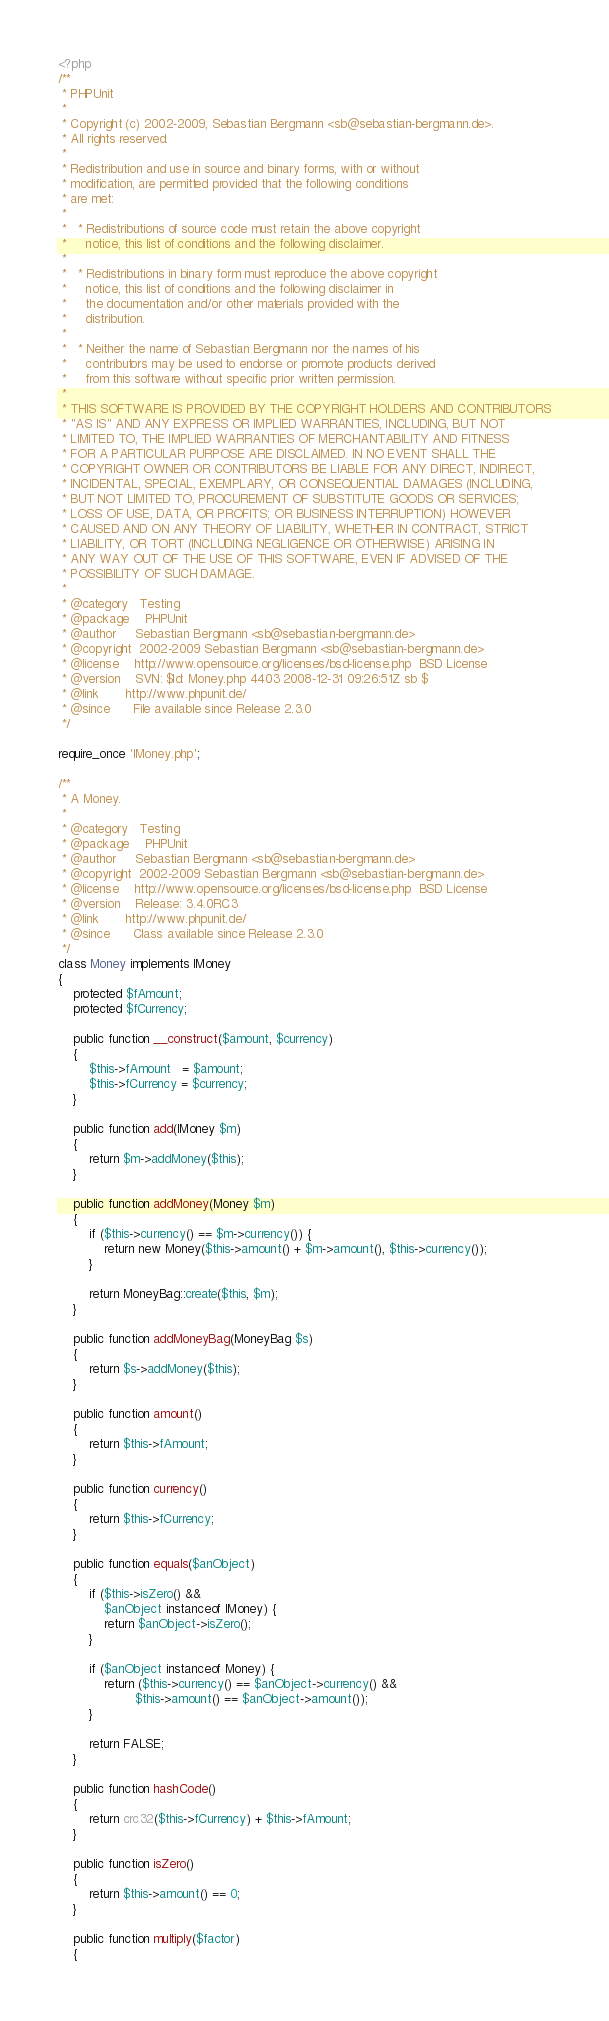<code> <loc_0><loc_0><loc_500><loc_500><_PHP_><?php
/**
 * PHPUnit
 *
 * Copyright (c) 2002-2009, Sebastian Bergmann <sb@sebastian-bergmann.de>.
 * All rights reserved.
 *
 * Redistribution and use in source and binary forms, with or without
 * modification, are permitted provided that the following conditions
 * are met:
 *
 *   * Redistributions of source code must retain the above copyright
 *     notice, this list of conditions and the following disclaimer.
 *
 *   * Redistributions in binary form must reproduce the above copyright
 *     notice, this list of conditions and the following disclaimer in
 *     the documentation and/or other materials provided with the
 *     distribution.
 *
 *   * Neither the name of Sebastian Bergmann nor the names of his
 *     contributors may be used to endorse or promote products derived
 *     from this software without specific prior written permission.
 *
 * THIS SOFTWARE IS PROVIDED BY THE COPYRIGHT HOLDERS AND CONTRIBUTORS
 * "AS IS" AND ANY EXPRESS OR IMPLIED WARRANTIES, INCLUDING, BUT NOT
 * LIMITED TO, THE IMPLIED WARRANTIES OF MERCHANTABILITY AND FITNESS
 * FOR A PARTICULAR PURPOSE ARE DISCLAIMED. IN NO EVENT SHALL THE
 * COPYRIGHT OWNER OR CONTRIBUTORS BE LIABLE FOR ANY DIRECT, INDIRECT,
 * INCIDENTAL, SPECIAL, EXEMPLARY, OR CONSEQUENTIAL DAMAGES (INCLUDING,
 * BUT NOT LIMITED TO, PROCUREMENT OF SUBSTITUTE GOODS OR SERVICES;
 * LOSS OF USE, DATA, OR PROFITS; OR BUSINESS INTERRUPTION) HOWEVER
 * CAUSED AND ON ANY THEORY OF LIABILITY, WHETHER IN CONTRACT, STRICT
 * LIABILITY, OR TORT (INCLUDING NEGLIGENCE OR OTHERWISE) ARISING IN
 * ANY WAY OUT OF THE USE OF THIS SOFTWARE, EVEN IF ADVISED OF THE
 * POSSIBILITY OF SUCH DAMAGE.
 *
 * @category   Testing
 * @package    PHPUnit
 * @author     Sebastian Bergmann <sb@sebastian-bergmann.de>
 * @copyright  2002-2009 Sebastian Bergmann <sb@sebastian-bergmann.de>
 * @license    http://www.opensource.org/licenses/bsd-license.php  BSD License
 * @version    SVN: $Id: Money.php 4403 2008-12-31 09:26:51Z sb $
 * @link       http://www.phpunit.de/
 * @since      File available since Release 2.3.0
 */

require_once 'IMoney.php';

/**
 * A Money.
 *
 * @category   Testing
 * @package    PHPUnit
 * @author     Sebastian Bergmann <sb@sebastian-bergmann.de>
 * @copyright  2002-2009 Sebastian Bergmann <sb@sebastian-bergmann.de>
 * @license    http://www.opensource.org/licenses/bsd-license.php  BSD License
 * @version    Release: 3.4.0RC3
 * @link       http://www.phpunit.de/
 * @since      Class available since Release 2.3.0
 */
class Money implements IMoney
{
    protected $fAmount;
    protected $fCurrency;

    public function __construct($amount, $currency)
    {
        $this->fAmount   = $amount;
        $this->fCurrency = $currency;
    }

    public function add(IMoney $m)
    {
        return $m->addMoney($this);
    }

    public function addMoney(Money $m)
    {
        if ($this->currency() == $m->currency()) {
            return new Money($this->amount() + $m->amount(), $this->currency());
        }

        return MoneyBag::create($this, $m);
    }

    public function addMoneyBag(MoneyBag $s)
    {
        return $s->addMoney($this);
    }

    public function amount()
    {
        return $this->fAmount;
    }

    public function currency()
    {
        return $this->fCurrency;
    }

    public function equals($anObject)
    {
        if ($this->isZero() &&
            $anObject instanceof IMoney) {
            return $anObject->isZero();
        }

        if ($anObject instanceof Money) {
            return ($this->currency() == $anObject->currency() &&
                    $this->amount() == $anObject->amount());
        }

        return FALSE;
    }

    public function hashCode()
    {
        return crc32($this->fCurrency) + $this->fAmount;
    }

    public function isZero()
    {
        return $this->amount() == 0;
    }

    public function multiply($factor)
    {</code> 